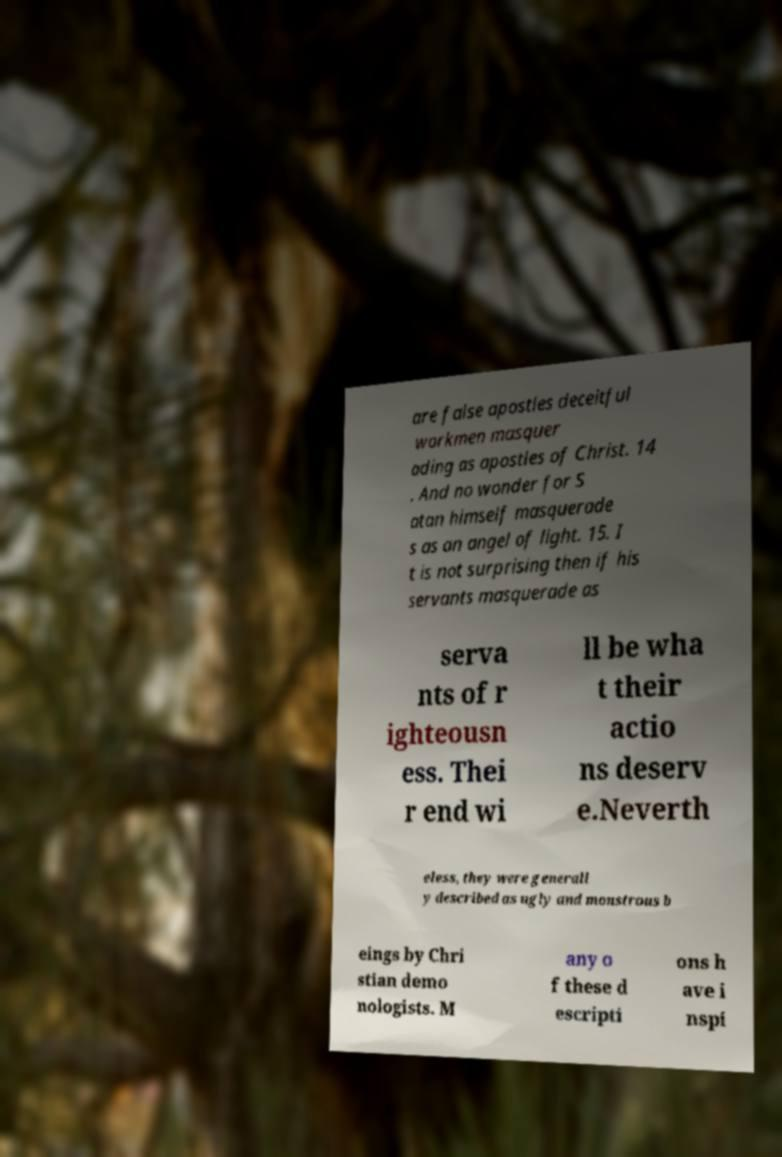Could you assist in decoding the text presented in this image and type it out clearly? are false apostles deceitful workmen masquer ading as apostles of Christ. 14 . And no wonder for S atan himself masquerade s as an angel of light. 15. I t is not surprising then if his servants masquerade as serva nts of r ighteousn ess. Thei r end wi ll be wha t their actio ns deserv e.Neverth eless, they were generall y described as ugly and monstrous b eings by Chri stian demo nologists. M any o f these d escripti ons h ave i nspi 